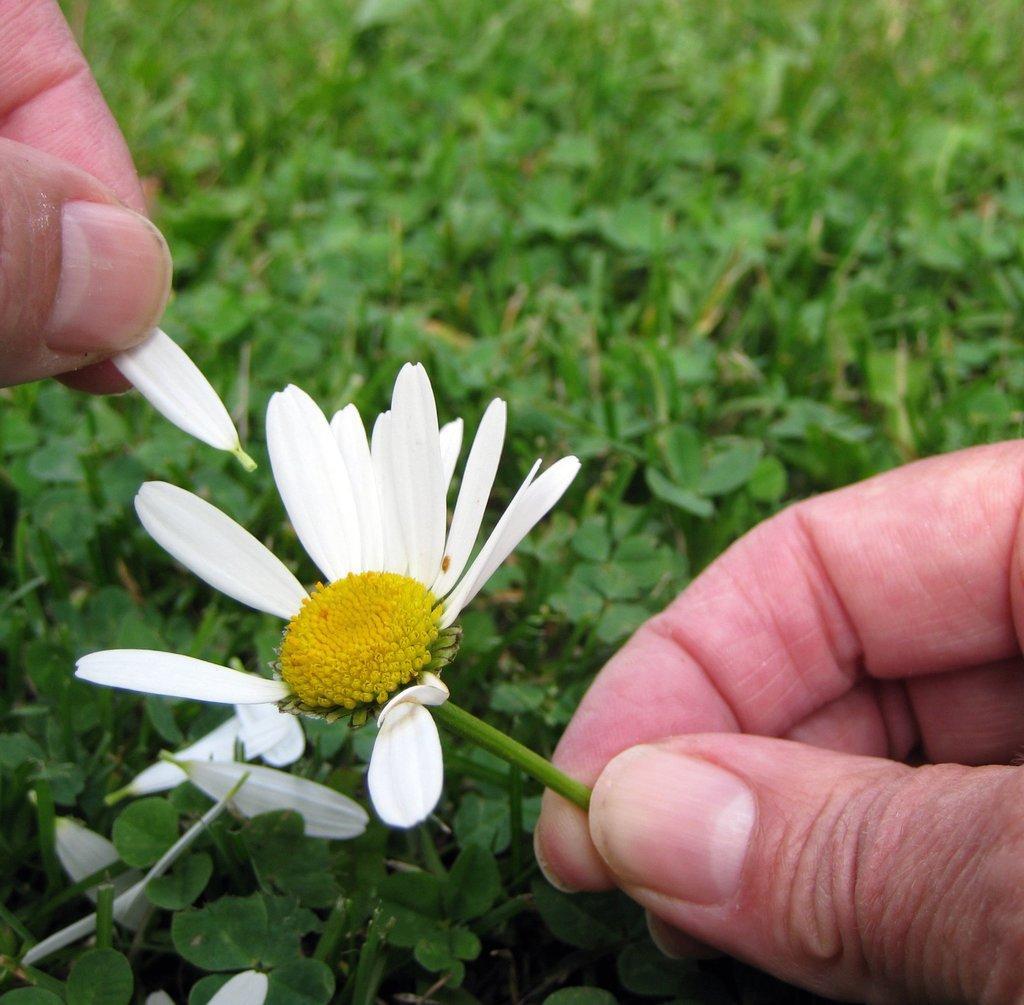How would you summarize this image in a sentence or two? In this image we can see person´s fingers holding a flower and a petal and there are few plants in the background. 